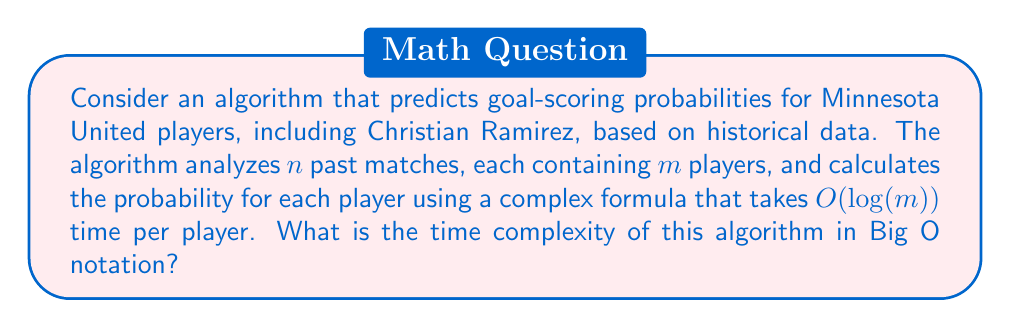Help me with this question. To determine the time complexity of this algorithm, let's break it down step by step:

1. The algorithm analyzes $n$ past matches.

2. For each match, it processes $m$ players.

3. For each player, it calculates the probability using a formula that takes $O(log(m))$ time.

Therefore, we can express the total time complexity as:

$$ T(n,m) = n \cdot m \cdot O(log(m)) $$

This can be simplified to:

$$ T(n,m) = O(n \cdot m \cdot log(m)) $$

The time complexity is dominated by the product of the number of matches, the number of players per match, and the logarithm of the number of players.

It's worth noting that this complexity assumes that the number of players $m$ is constant across all matches. If $m$ varies, we would use the maximum value of $m$ to ensure an upper bound on the time complexity.
Answer: $O(n \cdot m \cdot log(m))$ 